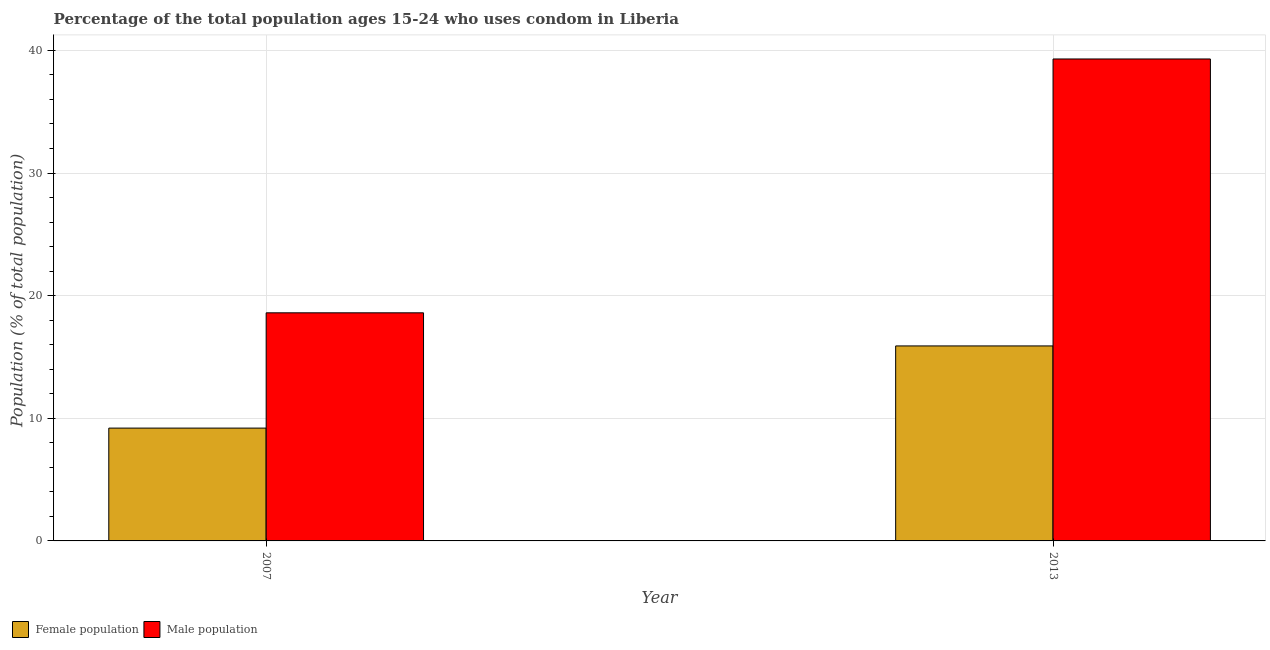How many groups of bars are there?
Provide a short and direct response. 2. Are the number of bars per tick equal to the number of legend labels?
Provide a succinct answer. Yes. Are the number of bars on each tick of the X-axis equal?
Keep it short and to the point. Yes. How many bars are there on the 1st tick from the right?
Your answer should be very brief. 2. What is the male population in 2013?
Provide a succinct answer. 39.3. In which year was the female population maximum?
Ensure brevity in your answer.  2013. In which year was the female population minimum?
Offer a very short reply. 2007. What is the total female population in the graph?
Your answer should be compact. 25.1. What is the difference between the male population in 2007 and that in 2013?
Provide a succinct answer. -20.7. What is the difference between the female population in 2013 and the male population in 2007?
Ensure brevity in your answer.  6.7. What is the average female population per year?
Provide a short and direct response. 12.55. What is the ratio of the male population in 2007 to that in 2013?
Ensure brevity in your answer.  0.47. Is the female population in 2007 less than that in 2013?
Your answer should be compact. Yes. What does the 2nd bar from the left in 2013 represents?
Offer a very short reply. Male population. What does the 1st bar from the right in 2007 represents?
Your answer should be compact. Male population. Are all the bars in the graph horizontal?
Keep it short and to the point. No. Where does the legend appear in the graph?
Keep it short and to the point. Bottom left. How many legend labels are there?
Offer a very short reply. 2. How are the legend labels stacked?
Your answer should be very brief. Horizontal. What is the title of the graph?
Ensure brevity in your answer.  Percentage of the total population ages 15-24 who uses condom in Liberia. What is the label or title of the X-axis?
Provide a short and direct response. Year. What is the label or title of the Y-axis?
Provide a short and direct response. Population (% of total population) . What is the Population (% of total population)  in Male population in 2013?
Give a very brief answer. 39.3. Across all years, what is the maximum Population (% of total population)  in Female population?
Offer a terse response. 15.9. Across all years, what is the maximum Population (% of total population)  of Male population?
Your answer should be compact. 39.3. Across all years, what is the minimum Population (% of total population)  in Male population?
Your answer should be very brief. 18.6. What is the total Population (% of total population)  in Female population in the graph?
Offer a terse response. 25.1. What is the total Population (% of total population)  of Male population in the graph?
Ensure brevity in your answer.  57.9. What is the difference between the Population (% of total population)  in Female population in 2007 and that in 2013?
Your answer should be compact. -6.7. What is the difference between the Population (% of total population)  of Male population in 2007 and that in 2013?
Your response must be concise. -20.7. What is the difference between the Population (% of total population)  of Female population in 2007 and the Population (% of total population)  of Male population in 2013?
Your answer should be very brief. -30.1. What is the average Population (% of total population)  in Female population per year?
Offer a terse response. 12.55. What is the average Population (% of total population)  in Male population per year?
Provide a short and direct response. 28.95. In the year 2013, what is the difference between the Population (% of total population)  of Female population and Population (% of total population)  of Male population?
Make the answer very short. -23.4. What is the ratio of the Population (% of total population)  of Female population in 2007 to that in 2013?
Your answer should be very brief. 0.58. What is the ratio of the Population (% of total population)  of Male population in 2007 to that in 2013?
Ensure brevity in your answer.  0.47. What is the difference between the highest and the second highest Population (% of total population)  of Male population?
Provide a short and direct response. 20.7. What is the difference between the highest and the lowest Population (% of total population)  in Female population?
Ensure brevity in your answer.  6.7. What is the difference between the highest and the lowest Population (% of total population)  of Male population?
Give a very brief answer. 20.7. 